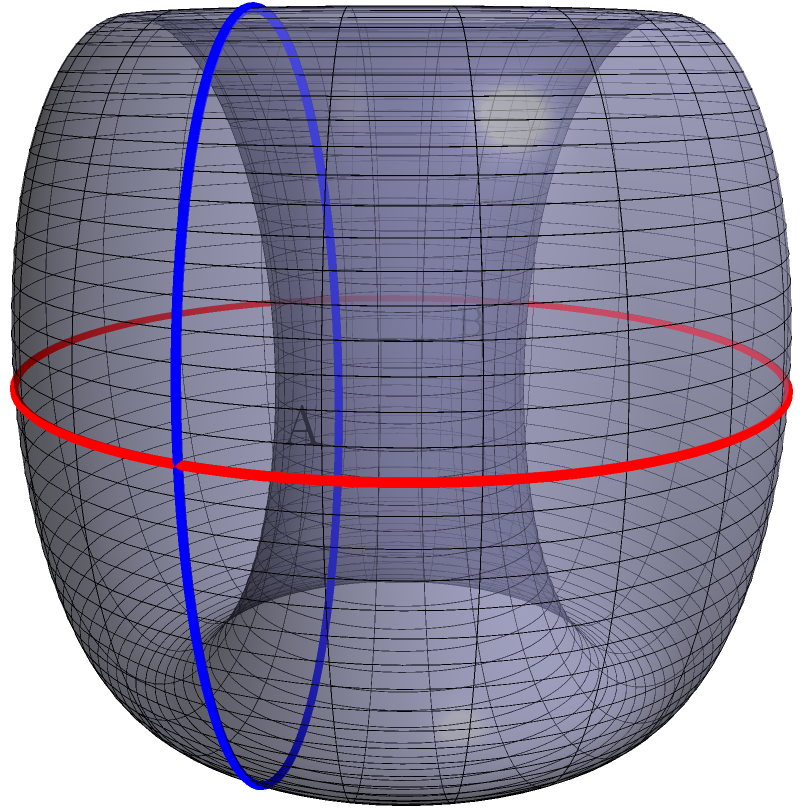On the surface of a Klein bottle, as shown in the diagram, consider two points A and B located on opposite sides of the bottle's "neck". If the shortest path between A and B along the surface has a length of 6 units, what is the approximate circumference of the bottle's main body, assuming it's roughly circular? How might this non-Euclidean geometry impact our understanding of corporate structures and wealth distribution in a global economy? To solve this problem and understand its implications, let's follow these steps:

1) In non-Euclidean geometry, particularly on a Klein bottle, the shortest path between two points can be counterintuitive. The path from A to B might wrap around the bottle's surface in unexpected ways.

2) Given that the shortest path between A and B is 6 units, we can estimate that this is approximately half the circumference of the main body. This is because the Klein bottle's surface allows a path to traverse from one side to the other without crossing an edge.

3) If 6 units is roughly half the circumference, then the full circumference would be approximately 12 units.

4) To calculate the radius, we can use the formula for circumference: $C = 2\pi r$
   $12 = 2\pi r$
   $r = \frac{12}{2\pi} \approx 1.91$ units

5) This non-Euclidean geometry can be seen as a metaphor for the complex, interconnected nature of global corporate structures. Just as the surface of a Klein bottle is non-orientable and can be traversed in unexpected ways, so too can wealth and influence flow through corporate networks in ways that aren't immediately apparent in a traditional, Euclidean framework.

6) The concept of "opposite sides" being connected (as with points A and B) could represent how seemingly distant parts of the global economy are actually closely linked. This interconnectedness highlights the need for comprehensive, global approaches to corporate regulation and taxation.

7) The non-intuitive nature of distances on a Klein bottle surface could symbolize how traditional metrics of corporate size or influence might not accurately capture their true reach or impact in a global, interconnected economy.

8) This perspective underscores the importance of progressive policies that consider the complex, non-linear relationships in global corporate structures when designing regulations and tax policies.
Answer: Approximately 12 units 